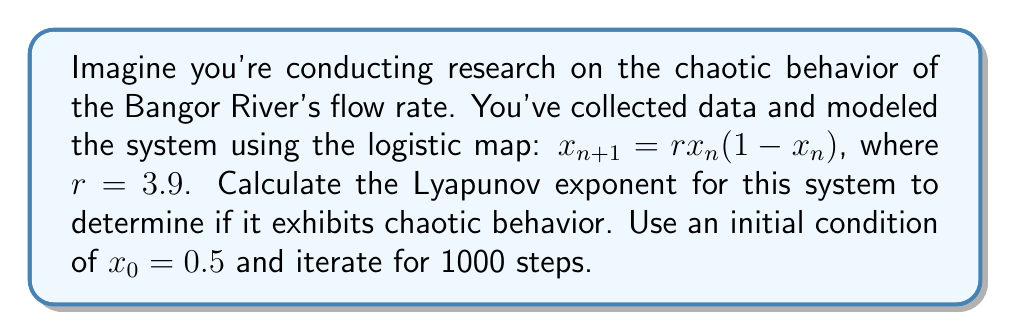Provide a solution to this math problem. To calculate the Lyapunov exponent for the given logistic map:

1. The formula for the Lyapunov exponent ($\lambda$) is:

   $$\lambda = \lim_{n \to \infty} \frac{1}{n} \sum_{i=0}^{n-1} \ln |f'(x_i)|$$

2. For the logistic map, $f(x) = rx(1-x)$, so $f'(x) = r(1-2x)$

3. Iterate the map for 1000 steps:
   $x_{i+1} = 3.9x_i(1-x_i)$, starting with $x_0 = 0.5$

4. For each iteration, calculate $\ln |f'(x_i)| = \ln |3.9(1-2x_i)|$

5. Sum these values:
   $$S = \sum_{i=0}^{999} \ln |3.9(1-2x_i)|$$

6. Calculate the Lyapunov exponent:
   $$\lambda = \frac{S}{1000}$$

7. Using a computer or calculator to perform these iterations and calculations, we get:
   $$\lambda \approx 0.5648$$

8. Since $\lambda > 0$, the system exhibits chaotic behavior.
Answer: $\lambda \approx 0.5648$ 